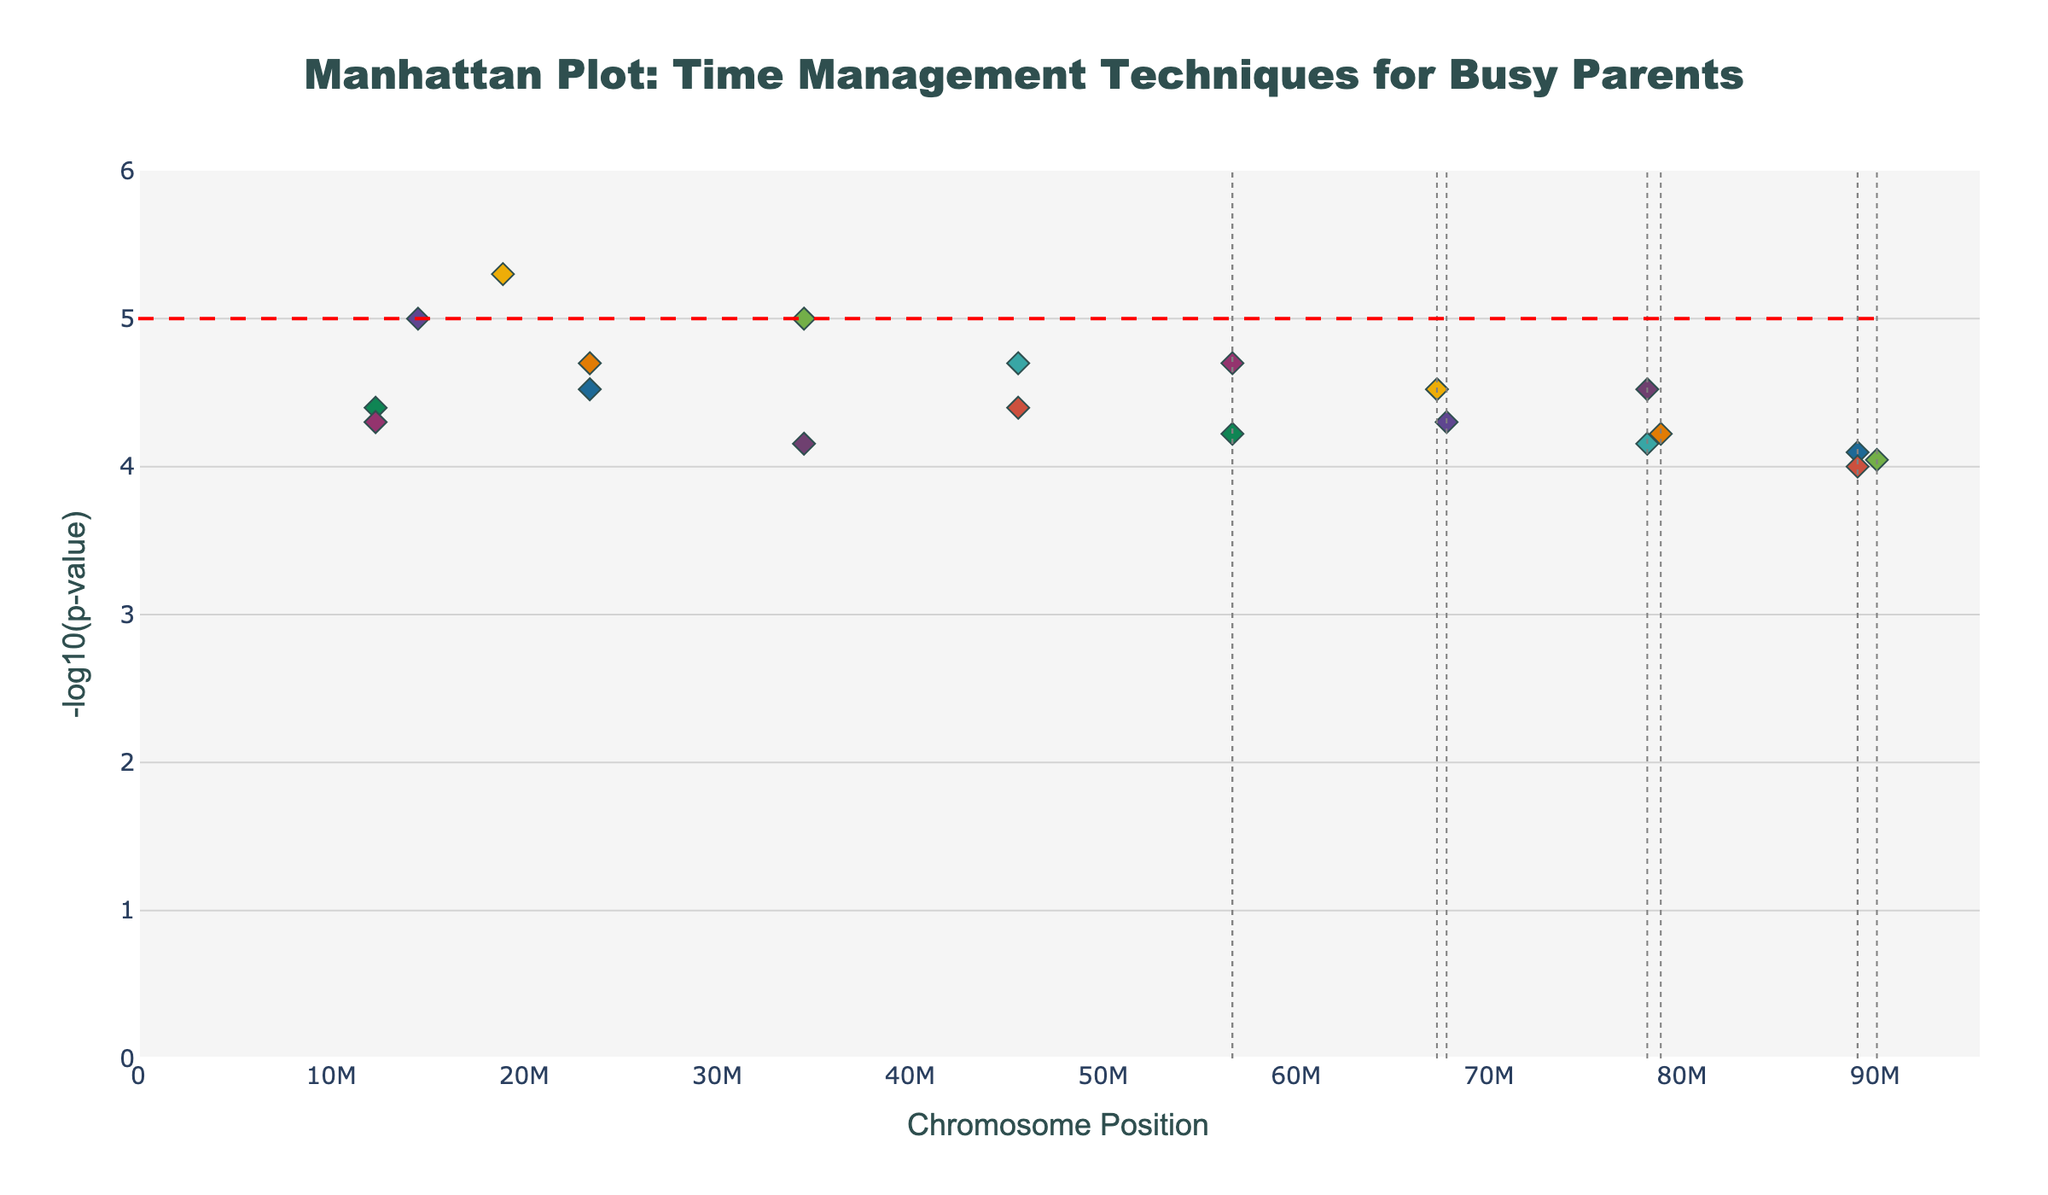What is the title of the plot? The title of the plot is displayed at the top center of the figure. It reads, "Manhattan Plot: Time Management Techniques for Busy Parents".
Answer: Manhattan Plot: Time Management Techniques for Busy Parents How many chromosomes are represented in the plot? To determine the number of chromosomes, count the distinct chromosome labels or colors used in the plot. There are 10 different chromosomes shown.
Answer: 10 Which time management technique has the lowest p-value on Chromosome 1? We need to look at the y-axis since lower p-values are transformed to higher -log10(p) values. The highest point on Chromosome 1 corresponds to "Meal_planning".
Answer: Meal_planning Based on the p-values, which technique appears most statistically significant across all chromosomes? The most statistically significant technique will be the one with the highest -log10(p) value. This value corresponds to the lowest p-value, which can be identified as "Prioritization" as it has the highest -log10(p) value.
Answer: Prioritization Is there any technique on Chromosome 3 that is above the significance threshold line? Yes, we determine this by looking for points on Chromosome 3 which have a -log10(p) value above 5. The "Automate_bill_payments" technique is above the threshold.
Answer: Automate_bill_payments Which chromosomes have the fewest and the most data points? We can count the number of points for each chromosome. Chromosome 9 has the fewest points with 2 data points, and Chromosomes 5 and 6 have the most with 3 data points each.
Answer: Fewest: Chromosome 9; Most: Chromosomes 5 and 6 What is the -log10(p) value for "Family_chore_chart"? Find "Family_chore_chart" in the plot and note the y-axis value. It is approximately between 4.6 and 4.7.
Answer: Around 4.7 Comparing "Shared_calendar" and "Online_shopping", which has a lower p-value? The point higher up on the -log10(p) axis corresponds to the lower p-value. "Online_shopping" at approximately 4.4 is higher than "Shared_calendar" at 4.1. Hence "Online_shopping" has a lower p-value.
Answer: Online_shopping What's the range of chromosome positions represented? To find this, observe the x-axis which spans from 0 (minimum position) to the maximum position. In the given data, this range is from 0 to 89100000 (position of Multitasking on Chromosome 8, the farthest along the x-axis).
Answer: 0 to 89100000 Are there any chromosomes where no techniques reach statistical significance? Statistical significance is shown by points above the red dashed line. Chromosomes 4 and 8 have no such points crossing this line.
Answer: Chromosomes 4 and 8 